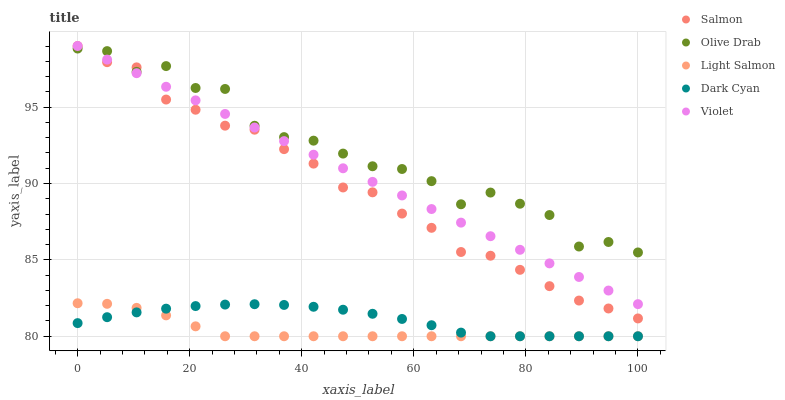Does Light Salmon have the minimum area under the curve?
Answer yes or no. Yes. Does Olive Drab have the maximum area under the curve?
Answer yes or no. Yes. Does Salmon have the minimum area under the curve?
Answer yes or no. No. Does Salmon have the maximum area under the curve?
Answer yes or no. No. Is Violet the smoothest?
Answer yes or no. Yes. Is Olive Drab the roughest?
Answer yes or no. Yes. Is Light Salmon the smoothest?
Answer yes or no. No. Is Light Salmon the roughest?
Answer yes or no. No. Does Dark Cyan have the lowest value?
Answer yes or no. Yes. Does Salmon have the lowest value?
Answer yes or no. No. Does Violet have the highest value?
Answer yes or no. Yes. Does Light Salmon have the highest value?
Answer yes or no. No. Is Dark Cyan less than Violet?
Answer yes or no. Yes. Is Violet greater than Light Salmon?
Answer yes or no. Yes. Does Light Salmon intersect Dark Cyan?
Answer yes or no. Yes. Is Light Salmon less than Dark Cyan?
Answer yes or no. No. Is Light Salmon greater than Dark Cyan?
Answer yes or no. No. Does Dark Cyan intersect Violet?
Answer yes or no. No. 